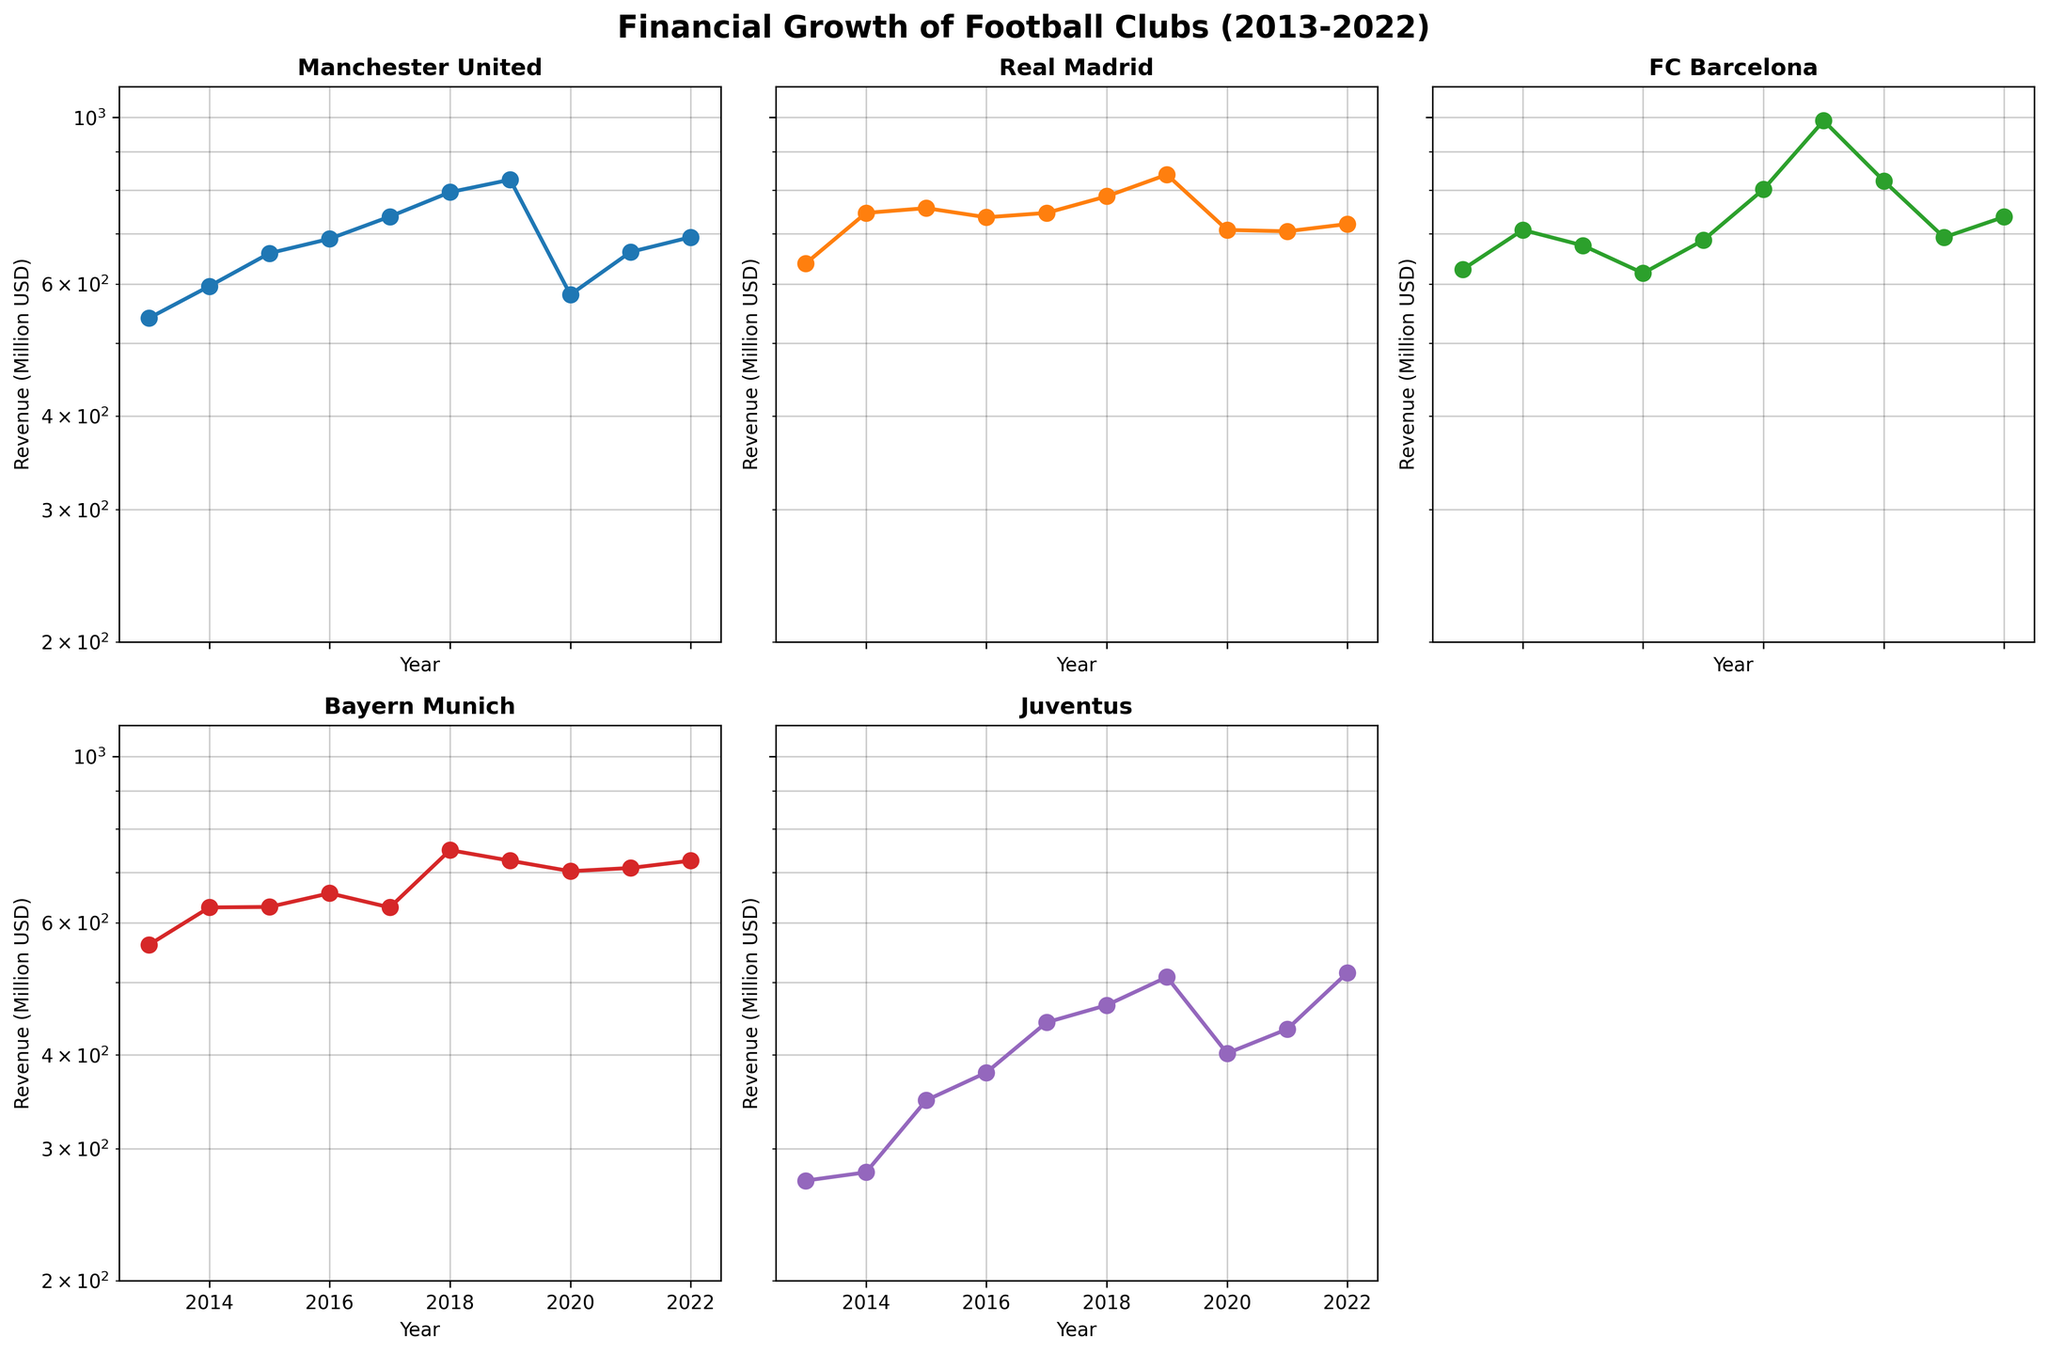Which club had the highest revenue in 2019? To determine this, we need to look at the 2019 data points in the figure and compare the heights of the lines for each club. The subplot with "FC Barcelona" shows the highest value around 990 million USD.
Answer: FC Barcelona What is the general trend of revenue for Manchester United from 2013 to 2022? Observing the subplot for Manchester United reveals a general upward trend with a small dip around 2020, followed by recovery in subsequent years.
Answer: Upward trend Between Bayern Munich and Juventus in 2022, which club had higher revenue? Compare the height of the data points for Bayern Munich and Juventus in the year 2022. Bayern Munich's data point is higher with approximately 726 million USD compared to Juventus' 515 million USD.
Answer: Bayern Munich How does Real Madrid's revenue in 2016 compare to 2013? Look at the revenue data points for Real Madrid in 2013 and 2016. In 2013, revenue is around 639 million USD whereas, in 2016, it is slightly lower at 736 million USD.
Answer: Slightly lower in 2016 Which club had the largest drop in revenue in 2020 compared to 2019? Find the steepest decline by comparing the 2019 and 2020 data points across subplots. FC Barcelona had a significant drop from around 990 million USD in 2019 to approximately 823 million USD in 2020.
Answer: FC Barcelona Based on the plots, which club experienced the most consistent growth over the decade? To assess consistency, look for the subplot with the smoothest upward trend. Juventus shows a steady and consistent increase in revenue compared to other clubs.
Answer: Juventus What is the estimated revenue for Manchester United in 2020, and how does it compare to the previous year? Check Manchester United's subplot for the data points in 2019 and 2020. The revenue in 2020 is approximately 580.4 million USD, compared to 826 million USD in 2019, showing a decline.
Answer: 580.4 million USD, decline How does FC Barcelona's revenue in 2018 compare to Juventus' in 2022? Look at the height of data points for FC Barcelona in 2018 and Juventus in 2022. FC Barcelona in 2018 has approximately 802 million USD, whereas Juventus in 2022 is around 515 million USD.
Answer: Higher for FC Barcelona in 2018 What's the general trend for Bayern Munich's revenue from 2013 to 2022? Observing Bayern Munich's subplot, we see small fluctuations but generally an upward trend, maintaining relatively steady growth over the period.
Answer: Upward trend with fluctuations Which club had the highest revenue in 2021? Compare the 2021 data points for all clubs. Manchester United had the highest revenue with approximately 661.7 million USD.
Answer: Manchester United 